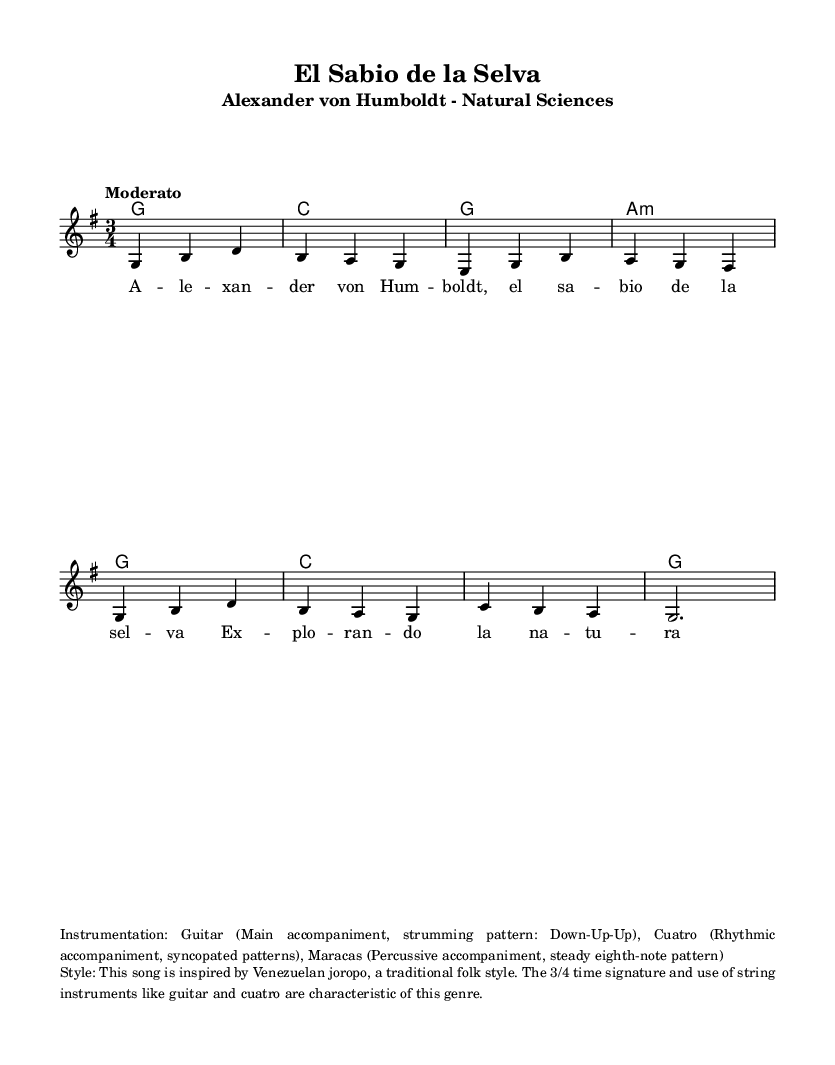What is the key signature of this music? The key signature is G major, which has one sharp (F#). This is indicated at the beginning of the staff in the key signature area.
Answer: G major What is the time signature of this music? The time signature is 3/4, which is visible at the beginning of the piece. This indicates there are three beats per measure, and the quarter note gets one beat.
Answer: 3/4 What is the tempo marking for this piece? The tempo marking is "Moderato," which indicates a moderate speed. This marking is typically found above the staff.
Answer: Moderato How many measures are in the melody section? There are eight measures in the melody section, which can be counted visually as each group of notes and rests separated by bar lines represents one measure.
Answer: 8 What genre of Latin folk music is this song inspired by? The song is inspired by Venezuelan joropo, as noted in the additional information provided in the markup. This style is characterized by its lively rhythm and use of string instruments.
Answer: Venezuelan joropo Which historical figure does this song celebrate? This song celebrates Alexander von Humboldt, who is mentioned in the title and lyrics as the "sensible de la selva," or wise one of the jungle, connecting him to natural sciences.
Answer: Alexander von Humboldt 